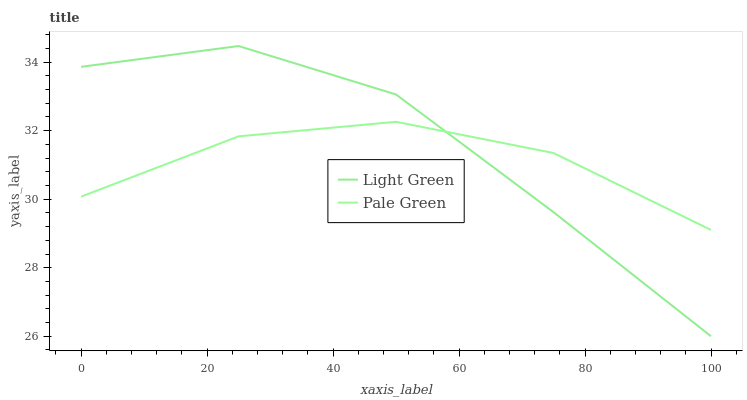Does Pale Green have the minimum area under the curve?
Answer yes or no. Yes. Does Light Green have the maximum area under the curve?
Answer yes or no. Yes. Does Light Green have the minimum area under the curve?
Answer yes or no. No. Is Pale Green the smoothest?
Answer yes or no. Yes. Is Light Green the roughest?
Answer yes or no. Yes. Is Light Green the smoothest?
Answer yes or no. No. Does Light Green have the lowest value?
Answer yes or no. Yes. Does Light Green have the highest value?
Answer yes or no. Yes. Does Pale Green intersect Light Green?
Answer yes or no. Yes. Is Pale Green less than Light Green?
Answer yes or no. No. Is Pale Green greater than Light Green?
Answer yes or no. No. 